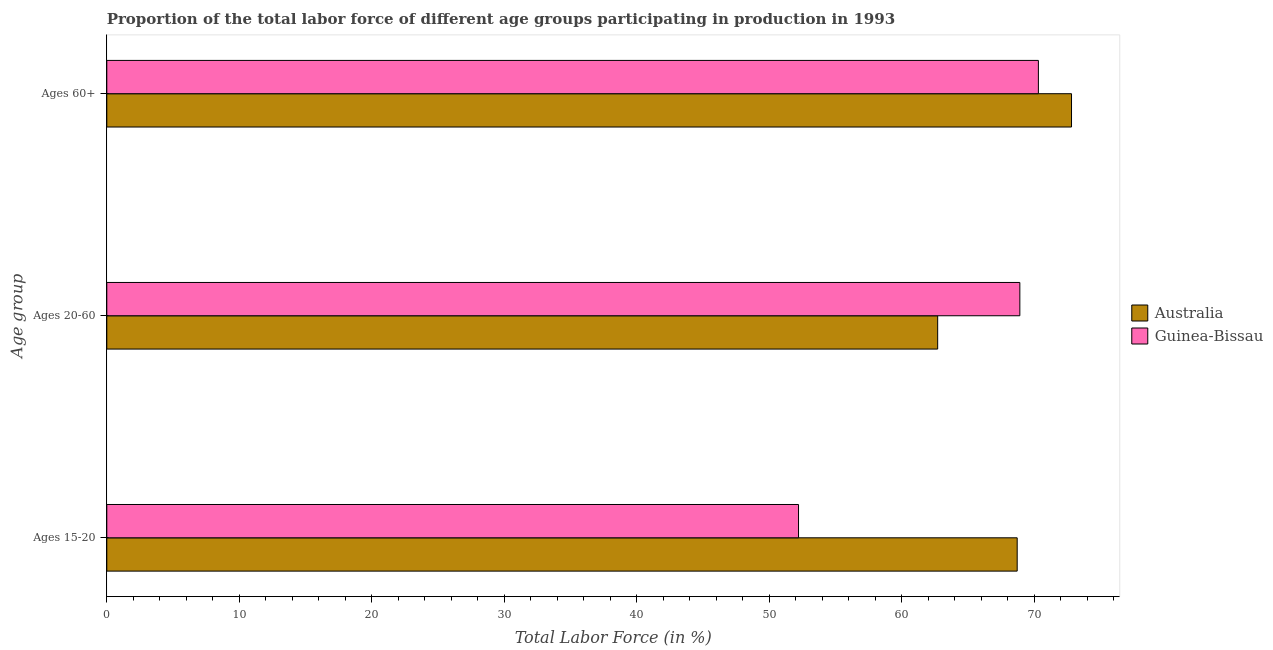How many different coloured bars are there?
Provide a short and direct response. 2. How many bars are there on the 3rd tick from the bottom?
Give a very brief answer. 2. What is the label of the 1st group of bars from the top?
Provide a succinct answer. Ages 60+. What is the percentage of labor force within the age group 15-20 in Guinea-Bissau?
Ensure brevity in your answer.  52.2. Across all countries, what is the maximum percentage of labor force within the age group 20-60?
Make the answer very short. 68.9. Across all countries, what is the minimum percentage of labor force above age 60?
Your answer should be compact. 70.3. In which country was the percentage of labor force within the age group 20-60 maximum?
Your response must be concise. Guinea-Bissau. In which country was the percentage of labor force within the age group 20-60 minimum?
Provide a succinct answer. Australia. What is the total percentage of labor force within the age group 15-20 in the graph?
Give a very brief answer. 120.9. What is the difference between the percentage of labor force within the age group 15-20 in Guinea-Bissau and the percentage of labor force within the age group 20-60 in Australia?
Your response must be concise. -10.5. What is the average percentage of labor force within the age group 15-20 per country?
Give a very brief answer. 60.45. What is the difference between the percentage of labor force within the age group 20-60 and percentage of labor force above age 60 in Guinea-Bissau?
Your answer should be compact. -1.4. What is the ratio of the percentage of labor force within the age group 20-60 in Guinea-Bissau to that in Australia?
Offer a terse response. 1.1. Is the percentage of labor force within the age group 20-60 in Australia less than that in Guinea-Bissau?
Your response must be concise. Yes. Is the difference between the percentage of labor force within the age group 20-60 in Australia and Guinea-Bissau greater than the difference between the percentage of labor force above age 60 in Australia and Guinea-Bissau?
Your response must be concise. No. What is the difference between the highest and the second highest percentage of labor force above age 60?
Ensure brevity in your answer.  2.5. In how many countries, is the percentage of labor force within the age group 20-60 greater than the average percentage of labor force within the age group 20-60 taken over all countries?
Offer a terse response. 1. What does the 1st bar from the top in Ages 20-60 represents?
Make the answer very short. Guinea-Bissau. What does the 1st bar from the bottom in Ages 20-60 represents?
Provide a short and direct response. Australia. Is it the case that in every country, the sum of the percentage of labor force within the age group 15-20 and percentage of labor force within the age group 20-60 is greater than the percentage of labor force above age 60?
Offer a very short reply. Yes. How many bars are there?
Your response must be concise. 6. Are all the bars in the graph horizontal?
Offer a very short reply. Yes. Are the values on the major ticks of X-axis written in scientific E-notation?
Your response must be concise. No. Does the graph contain grids?
Keep it short and to the point. No. How many legend labels are there?
Offer a very short reply. 2. How are the legend labels stacked?
Give a very brief answer. Vertical. What is the title of the graph?
Your answer should be very brief. Proportion of the total labor force of different age groups participating in production in 1993. What is the label or title of the X-axis?
Make the answer very short. Total Labor Force (in %). What is the label or title of the Y-axis?
Ensure brevity in your answer.  Age group. What is the Total Labor Force (in %) in Australia in Ages 15-20?
Make the answer very short. 68.7. What is the Total Labor Force (in %) of Guinea-Bissau in Ages 15-20?
Keep it short and to the point. 52.2. What is the Total Labor Force (in %) in Australia in Ages 20-60?
Offer a terse response. 62.7. What is the Total Labor Force (in %) of Guinea-Bissau in Ages 20-60?
Your answer should be very brief. 68.9. What is the Total Labor Force (in %) in Australia in Ages 60+?
Your response must be concise. 72.8. What is the Total Labor Force (in %) in Guinea-Bissau in Ages 60+?
Make the answer very short. 70.3. Across all Age group, what is the maximum Total Labor Force (in %) in Australia?
Give a very brief answer. 72.8. Across all Age group, what is the maximum Total Labor Force (in %) in Guinea-Bissau?
Offer a terse response. 70.3. Across all Age group, what is the minimum Total Labor Force (in %) of Australia?
Offer a terse response. 62.7. Across all Age group, what is the minimum Total Labor Force (in %) in Guinea-Bissau?
Ensure brevity in your answer.  52.2. What is the total Total Labor Force (in %) in Australia in the graph?
Provide a succinct answer. 204.2. What is the total Total Labor Force (in %) of Guinea-Bissau in the graph?
Your answer should be compact. 191.4. What is the difference between the Total Labor Force (in %) in Australia in Ages 15-20 and that in Ages 20-60?
Your response must be concise. 6. What is the difference between the Total Labor Force (in %) of Guinea-Bissau in Ages 15-20 and that in Ages 20-60?
Keep it short and to the point. -16.7. What is the difference between the Total Labor Force (in %) of Australia in Ages 15-20 and that in Ages 60+?
Your answer should be compact. -4.1. What is the difference between the Total Labor Force (in %) in Guinea-Bissau in Ages 15-20 and that in Ages 60+?
Give a very brief answer. -18.1. What is the difference between the Total Labor Force (in %) of Australia in Ages 20-60 and that in Ages 60+?
Provide a succinct answer. -10.1. What is the difference between the Total Labor Force (in %) of Guinea-Bissau in Ages 20-60 and that in Ages 60+?
Provide a short and direct response. -1.4. What is the difference between the Total Labor Force (in %) of Australia in Ages 15-20 and the Total Labor Force (in %) of Guinea-Bissau in Ages 20-60?
Provide a succinct answer. -0.2. What is the difference between the Total Labor Force (in %) in Australia in Ages 15-20 and the Total Labor Force (in %) in Guinea-Bissau in Ages 60+?
Keep it short and to the point. -1.6. What is the difference between the Total Labor Force (in %) of Australia in Ages 20-60 and the Total Labor Force (in %) of Guinea-Bissau in Ages 60+?
Offer a very short reply. -7.6. What is the average Total Labor Force (in %) in Australia per Age group?
Provide a succinct answer. 68.07. What is the average Total Labor Force (in %) in Guinea-Bissau per Age group?
Your response must be concise. 63.8. What is the difference between the Total Labor Force (in %) in Australia and Total Labor Force (in %) in Guinea-Bissau in Ages 20-60?
Your answer should be compact. -6.2. What is the difference between the Total Labor Force (in %) of Australia and Total Labor Force (in %) of Guinea-Bissau in Ages 60+?
Provide a succinct answer. 2.5. What is the ratio of the Total Labor Force (in %) of Australia in Ages 15-20 to that in Ages 20-60?
Provide a succinct answer. 1.1. What is the ratio of the Total Labor Force (in %) in Guinea-Bissau in Ages 15-20 to that in Ages 20-60?
Give a very brief answer. 0.76. What is the ratio of the Total Labor Force (in %) of Australia in Ages 15-20 to that in Ages 60+?
Your answer should be very brief. 0.94. What is the ratio of the Total Labor Force (in %) of Guinea-Bissau in Ages 15-20 to that in Ages 60+?
Give a very brief answer. 0.74. What is the ratio of the Total Labor Force (in %) in Australia in Ages 20-60 to that in Ages 60+?
Provide a short and direct response. 0.86. What is the ratio of the Total Labor Force (in %) of Guinea-Bissau in Ages 20-60 to that in Ages 60+?
Your response must be concise. 0.98. What is the difference between the highest and the second highest Total Labor Force (in %) in Guinea-Bissau?
Give a very brief answer. 1.4. What is the difference between the highest and the lowest Total Labor Force (in %) in Australia?
Provide a succinct answer. 10.1. What is the difference between the highest and the lowest Total Labor Force (in %) in Guinea-Bissau?
Keep it short and to the point. 18.1. 